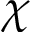<formula> <loc_0><loc_0><loc_500><loc_500>\chi</formula> 